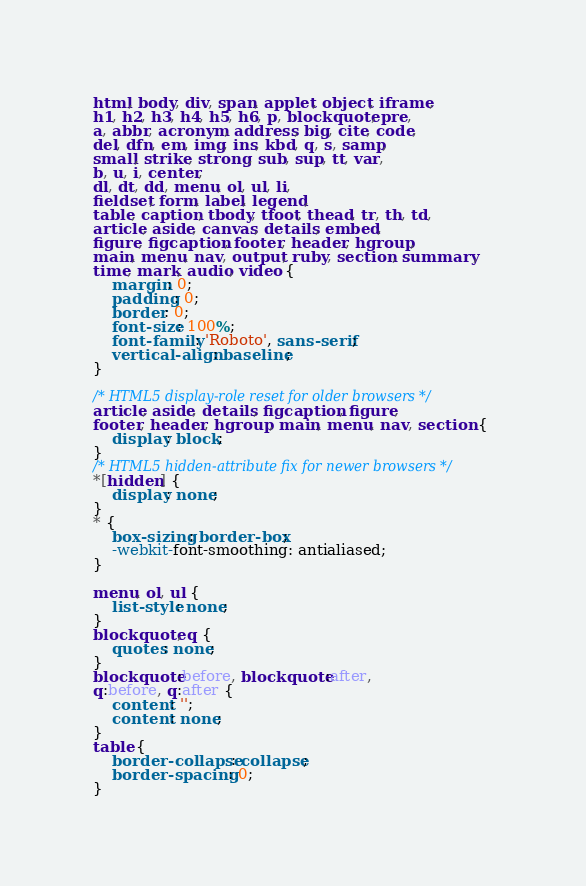<code> <loc_0><loc_0><loc_500><loc_500><_CSS_>html, body, div, span, applet, object, iframe,
h1, h2, h3, h4, h5, h6, p, blockquote, pre,
a, abbr, acronym, address, big, cite, code,
del, dfn, em, img, ins, kbd, q, s, samp,
small, strike, strong, sub, sup, tt, var,
b, u, i, center,
dl, dt, dd, menu, ol, ul, li,
fieldset, form, label, legend,
table, caption, tbody, tfoot, thead, tr, th, td,
article, aside, canvas, details, embed,
figure, figcaption, footer, header, hgroup,
main, menu, nav, output, ruby, section, summary,
time, mark, audio, video {
    margin: 0;
    padding: 0;
    border: 0;
    font-size: 100%;
    font-family: 'Roboto', sans-serif;
    vertical-align: baseline;
}

/* HTML5 display-role reset for older browsers */
article, aside, details, figcaption, figure,
footer, header, hgroup, main, menu, nav, section {
    display: block;
}
/* HTML5 hidden-attribute fix for newer browsers */
*[hidden] {
    display: none;
}
* {
    box-sizing: border-box;
    -webkit-font-smoothing: antialiased;
}

menu, ol, ul {
    list-style: none;
}
blockquote, q {
    quotes: none;
}
blockquote:before, blockquote:after,
q:before, q:after {
    content: '';
    content: none;
}
table {
    border-collapse: collapse;
    border-spacing: 0;
}
</code> 